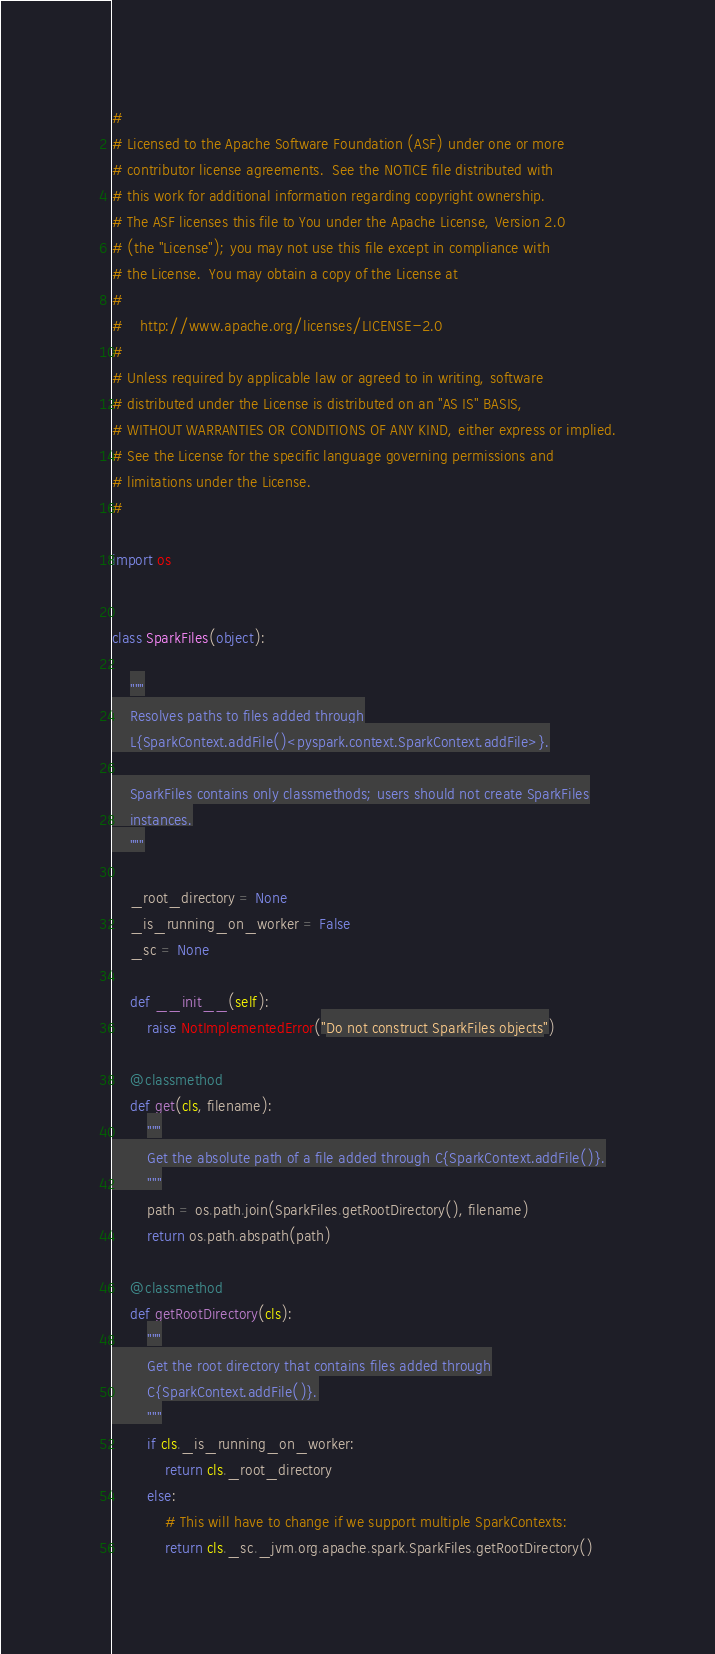<code> <loc_0><loc_0><loc_500><loc_500><_Python_>#
# Licensed to the Apache Software Foundation (ASF) under one or more
# contributor license agreements.  See the NOTICE file distributed with
# this work for additional information regarding copyright ownership.
# The ASF licenses this file to You under the Apache License, Version 2.0
# (the "License"); you may not use this file except in compliance with
# the License.  You may obtain a copy of the License at
#
#    http://www.apache.org/licenses/LICENSE-2.0
#
# Unless required by applicable law or agreed to in writing, software
# distributed under the License is distributed on an "AS IS" BASIS,
# WITHOUT WARRANTIES OR CONDITIONS OF ANY KIND, either express or implied.
# See the License for the specific language governing permissions and
# limitations under the License.
#

import os


class SparkFiles(object):

    """
    Resolves paths to files added through
    L{SparkContext.addFile()<pyspark.context.SparkContext.addFile>}.

    SparkFiles contains only classmethods; users should not create SparkFiles
    instances.
    """

    _root_directory = None
    _is_running_on_worker = False
    _sc = None

    def __init__(self):
        raise NotImplementedError("Do not construct SparkFiles objects")

    @classmethod
    def get(cls, filename):
        """
        Get the absolute path of a file added through C{SparkContext.addFile()}.
        """
        path = os.path.join(SparkFiles.getRootDirectory(), filename)
        return os.path.abspath(path)

    @classmethod
    def getRootDirectory(cls):
        """
        Get the root directory that contains files added through
        C{SparkContext.addFile()}.
        """
        if cls._is_running_on_worker:
            return cls._root_directory
        else:
            # This will have to change if we support multiple SparkContexts:
            return cls._sc._jvm.org.apache.spark.SparkFiles.getRootDirectory()
</code> 